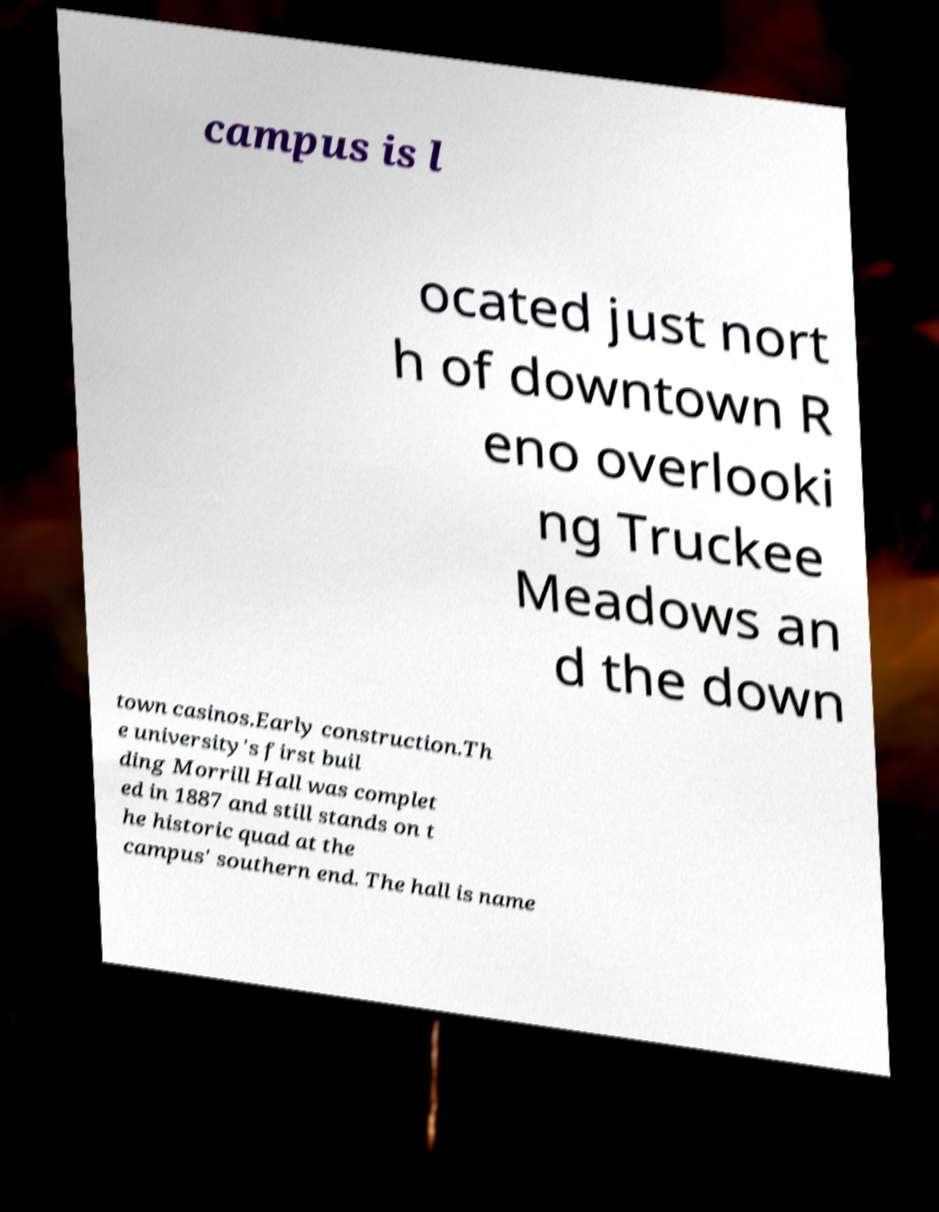For documentation purposes, I need the text within this image transcribed. Could you provide that? campus is l ocated just nort h of downtown R eno overlooki ng Truckee Meadows an d the down town casinos.Early construction.Th e university's first buil ding Morrill Hall was complet ed in 1887 and still stands on t he historic quad at the campus' southern end. The hall is name 